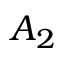Convert formula to latex. <formula><loc_0><loc_0><loc_500><loc_500>A _ { 2 }</formula> 